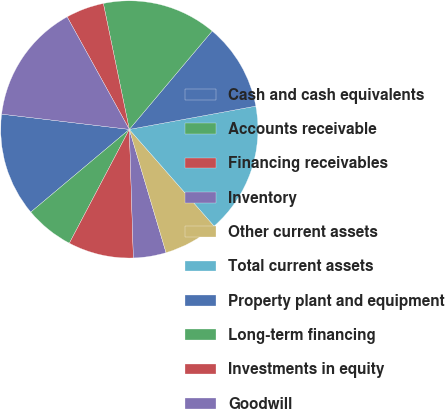Convert chart. <chart><loc_0><loc_0><loc_500><loc_500><pie_chart><fcel>Cash and cash equivalents<fcel>Accounts receivable<fcel>Financing receivables<fcel>Inventory<fcel>Other current assets<fcel>Total current assets<fcel>Property plant and equipment<fcel>Long-term financing<fcel>Investments in equity<fcel>Goodwill<nl><fcel>13.01%<fcel>6.17%<fcel>8.22%<fcel>4.11%<fcel>6.85%<fcel>16.44%<fcel>10.96%<fcel>14.38%<fcel>4.8%<fcel>15.07%<nl></chart> 